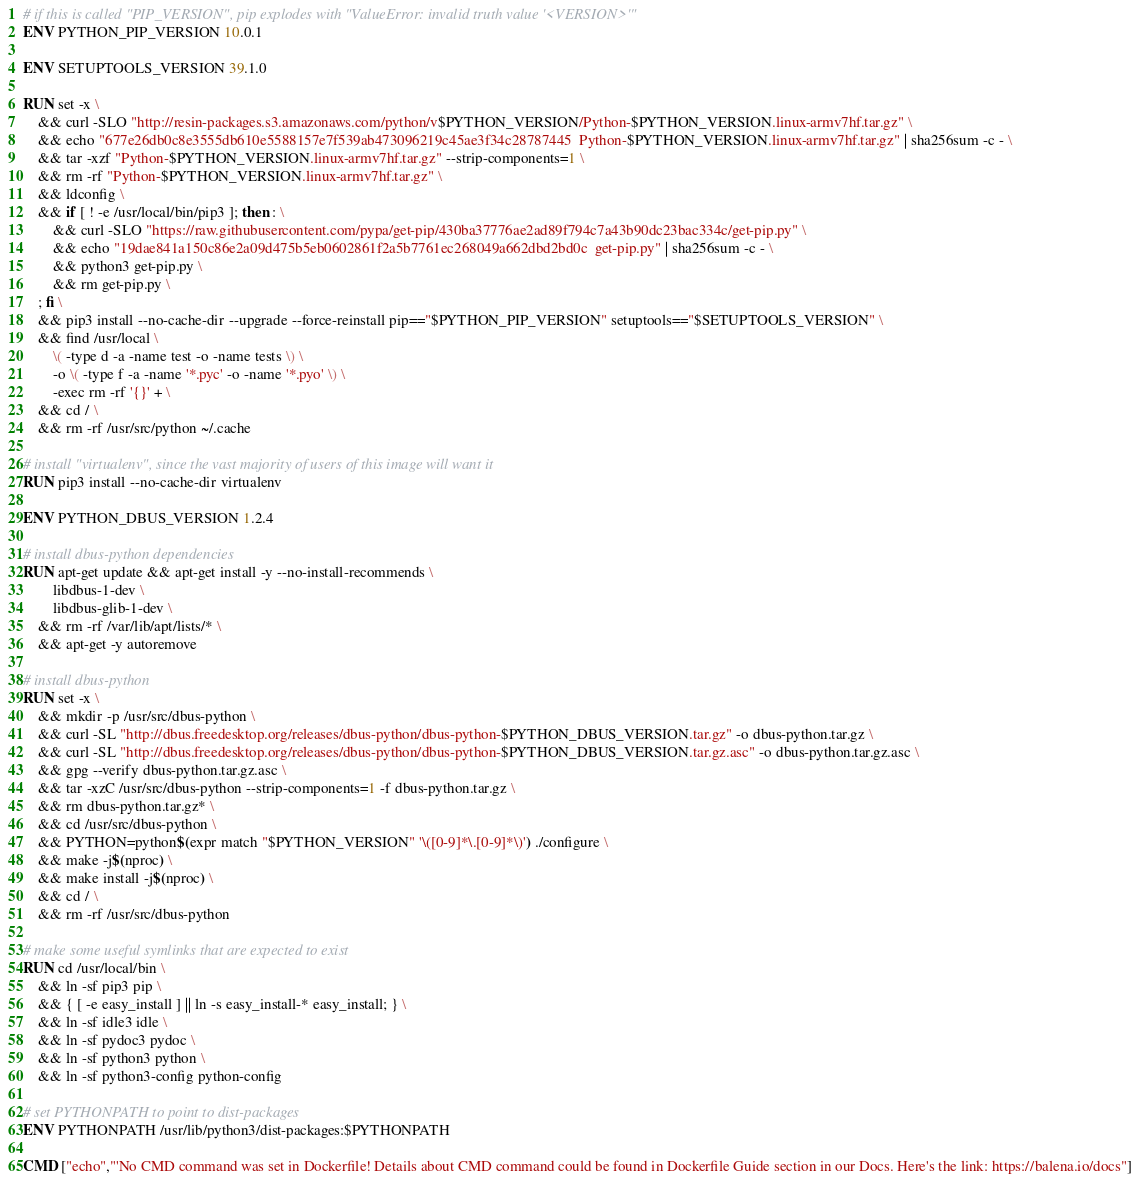Convert code to text. <code><loc_0><loc_0><loc_500><loc_500><_Dockerfile_>
# if this is called "PIP_VERSION", pip explodes with "ValueError: invalid truth value '<VERSION>'"
ENV PYTHON_PIP_VERSION 10.0.1

ENV SETUPTOOLS_VERSION 39.1.0

RUN set -x \
	&& curl -SLO "http://resin-packages.s3.amazonaws.com/python/v$PYTHON_VERSION/Python-$PYTHON_VERSION.linux-armv7hf.tar.gz" \
	&& echo "677e26db0c8e3555db610e5588157e7f539ab473096219c45ae3f34c28787445  Python-$PYTHON_VERSION.linux-armv7hf.tar.gz" | sha256sum -c - \
	&& tar -xzf "Python-$PYTHON_VERSION.linux-armv7hf.tar.gz" --strip-components=1 \
	&& rm -rf "Python-$PYTHON_VERSION.linux-armv7hf.tar.gz" \
	&& ldconfig \
	&& if [ ! -e /usr/local/bin/pip3 ]; then : \
		&& curl -SLO "https://raw.githubusercontent.com/pypa/get-pip/430ba37776ae2ad89f794c7a43b90dc23bac334c/get-pip.py" \
		&& echo "19dae841a150c86e2a09d475b5eb0602861f2a5b7761ec268049a662dbd2bd0c  get-pip.py" | sha256sum -c - \
		&& python3 get-pip.py \
		&& rm get-pip.py \
	; fi \
	&& pip3 install --no-cache-dir --upgrade --force-reinstall pip=="$PYTHON_PIP_VERSION" setuptools=="$SETUPTOOLS_VERSION" \
	&& find /usr/local \
		\( -type d -a -name test -o -name tests \) \
		-o \( -type f -a -name '*.pyc' -o -name '*.pyo' \) \
		-exec rm -rf '{}' + \
	&& cd / \
	&& rm -rf /usr/src/python ~/.cache

# install "virtualenv", since the vast majority of users of this image will want it
RUN pip3 install --no-cache-dir virtualenv

ENV PYTHON_DBUS_VERSION 1.2.4

# install dbus-python dependencies 
RUN apt-get update && apt-get install -y --no-install-recommends \
		libdbus-1-dev \
		libdbus-glib-1-dev \
	&& rm -rf /var/lib/apt/lists/* \
	&& apt-get -y autoremove

# install dbus-python
RUN set -x \
	&& mkdir -p /usr/src/dbus-python \
	&& curl -SL "http://dbus.freedesktop.org/releases/dbus-python/dbus-python-$PYTHON_DBUS_VERSION.tar.gz" -o dbus-python.tar.gz \
	&& curl -SL "http://dbus.freedesktop.org/releases/dbus-python/dbus-python-$PYTHON_DBUS_VERSION.tar.gz.asc" -o dbus-python.tar.gz.asc \
	&& gpg --verify dbus-python.tar.gz.asc \
	&& tar -xzC /usr/src/dbus-python --strip-components=1 -f dbus-python.tar.gz \
	&& rm dbus-python.tar.gz* \
	&& cd /usr/src/dbus-python \
	&& PYTHON=python$(expr match "$PYTHON_VERSION" '\([0-9]*\.[0-9]*\)') ./configure \
	&& make -j$(nproc) \
	&& make install -j$(nproc) \
	&& cd / \
	&& rm -rf /usr/src/dbus-python

# make some useful symlinks that are expected to exist
RUN cd /usr/local/bin \
	&& ln -sf pip3 pip \
	&& { [ -e easy_install ] || ln -s easy_install-* easy_install; } \
	&& ln -sf idle3 idle \
	&& ln -sf pydoc3 pydoc \
	&& ln -sf python3 python \
	&& ln -sf python3-config python-config

# set PYTHONPATH to point to dist-packages
ENV PYTHONPATH /usr/lib/python3/dist-packages:$PYTHONPATH

CMD ["echo","'No CMD command was set in Dockerfile! Details about CMD command could be found in Dockerfile Guide section in our Docs. Here's the link: https://balena.io/docs"]</code> 